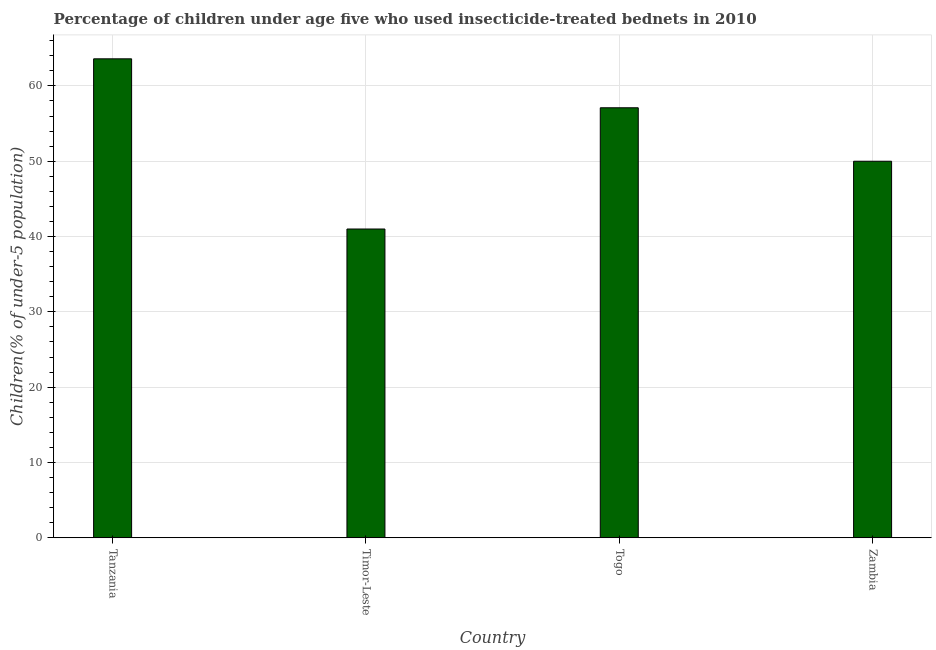What is the title of the graph?
Give a very brief answer. Percentage of children under age five who used insecticide-treated bednets in 2010. What is the label or title of the Y-axis?
Keep it short and to the point. Children(% of under-5 population). Across all countries, what is the maximum percentage of children who use of insecticide-treated bed nets?
Your response must be concise. 63.6. In which country was the percentage of children who use of insecticide-treated bed nets maximum?
Keep it short and to the point. Tanzania. In which country was the percentage of children who use of insecticide-treated bed nets minimum?
Give a very brief answer. Timor-Leste. What is the sum of the percentage of children who use of insecticide-treated bed nets?
Your answer should be very brief. 211.7. What is the difference between the percentage of children who use of insecticide-treated bed nets in Timor-Leste and Zambia?
Offer a terse response. -9. What is the average percentage of children who use of insecticide-treated bed nets per country?
Provide a short and direct response. 52.92. What is the median percentage of children who use of insecticide-treated bed nets?
Your response must be concise. 53.55. What is the ratio of the percentage of children who use of insecticide-treated bed nets in Timor-Leste to that in Zambia?
Make the answer very short. 0.82. Is the percentage of children who use of insecticide-treated bed nets in Tanzania less than that in Togo?
Your answer should be compact. No. Is the difference between the percentage of children who use of insecticide-treated bed nets in Timor-Leste and Togo greater than the difference between any two countries?
Offer a terse response. No. What is the difference between the highest and the second highest percentage of children who use of insecticide-treated bed nets?
Your answer should be very brief. 6.5. What is the difference between the highest and the lowest percentage of children who use of insecticide-treated bed nets?
Provide a short and direct response. 22.6. How many bars are there?
Provide a short and direct response. 4. Are all the bars in the graph horizontal?
Your response must be concise. No. Are the values on the major ticks of Y-axis written in scientific E-notation?
Make the answer very short. No. What is the Children(% of under-5 population) in Tanzania?
Your answer should be very brief. 63.6. What is the Children(% of under-5 population) of Timor-Leste?
Offer a very short reply. 41. What is the Children(% of under-5 population) of Togo?
Ensure brevity in your answer.  57.1. What is the Children(% of under-5 population) in Zambia?
Offer a very short reply. 50. What is the difference between the Children(% of under-5 population) in Tanzania and Timor-Leste?
Your response must be concise. 22.6. What is the difference between the Children(% of under-5 population) in Timor-Leste and Togo?
Your response must be concise. -16.1. What is the difference between the Children(% of under-5 population) in Timor-Leste and Zambia?
Your answer should be compact. -9. What is the ratio of the Children(% of under-5 population) in Tanzania to that in Timor-Leste?
Provide a succinct answer. 1.55. What is the ratio of the Children(% of under-5 population) in Tanzania to that in Togo?
Your answer should be very brief. 1.11. What is the ratio of the Children(% of under-5 population) in Tanzania to that in Zambia?
Your answer should be very brief. 1.27. What is the ratio of the Children(% of under-5 population) in Timor-Leste to that in Togo?
Provide a succinct answer. 0.72. What is the ratio of the Children(% of under-5 population) in Timor-Leste to that in Zambia?
Make the answer very short. 0.82. What is the ratio of the Children(% of under-5 population) in Togo to that in Zambia?
Provide a short and direct response. 1.14. 